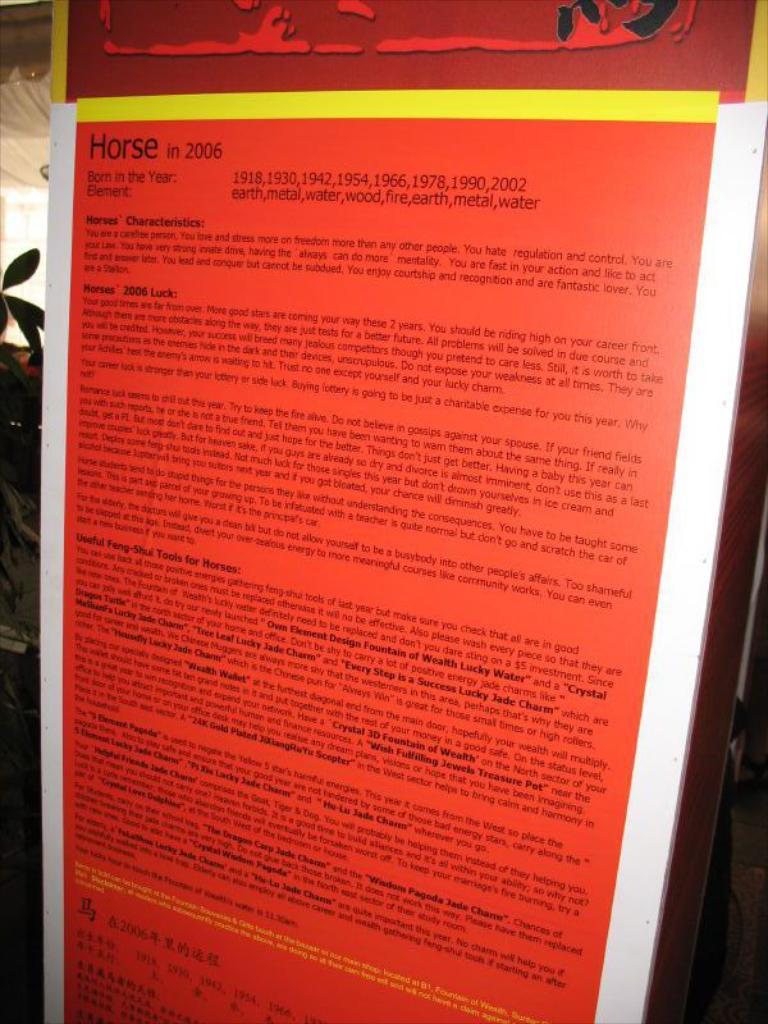<image>
Write a terse but informative summary of the picture. A plaque showing descriptions of the year of the horse and its characteristics. 